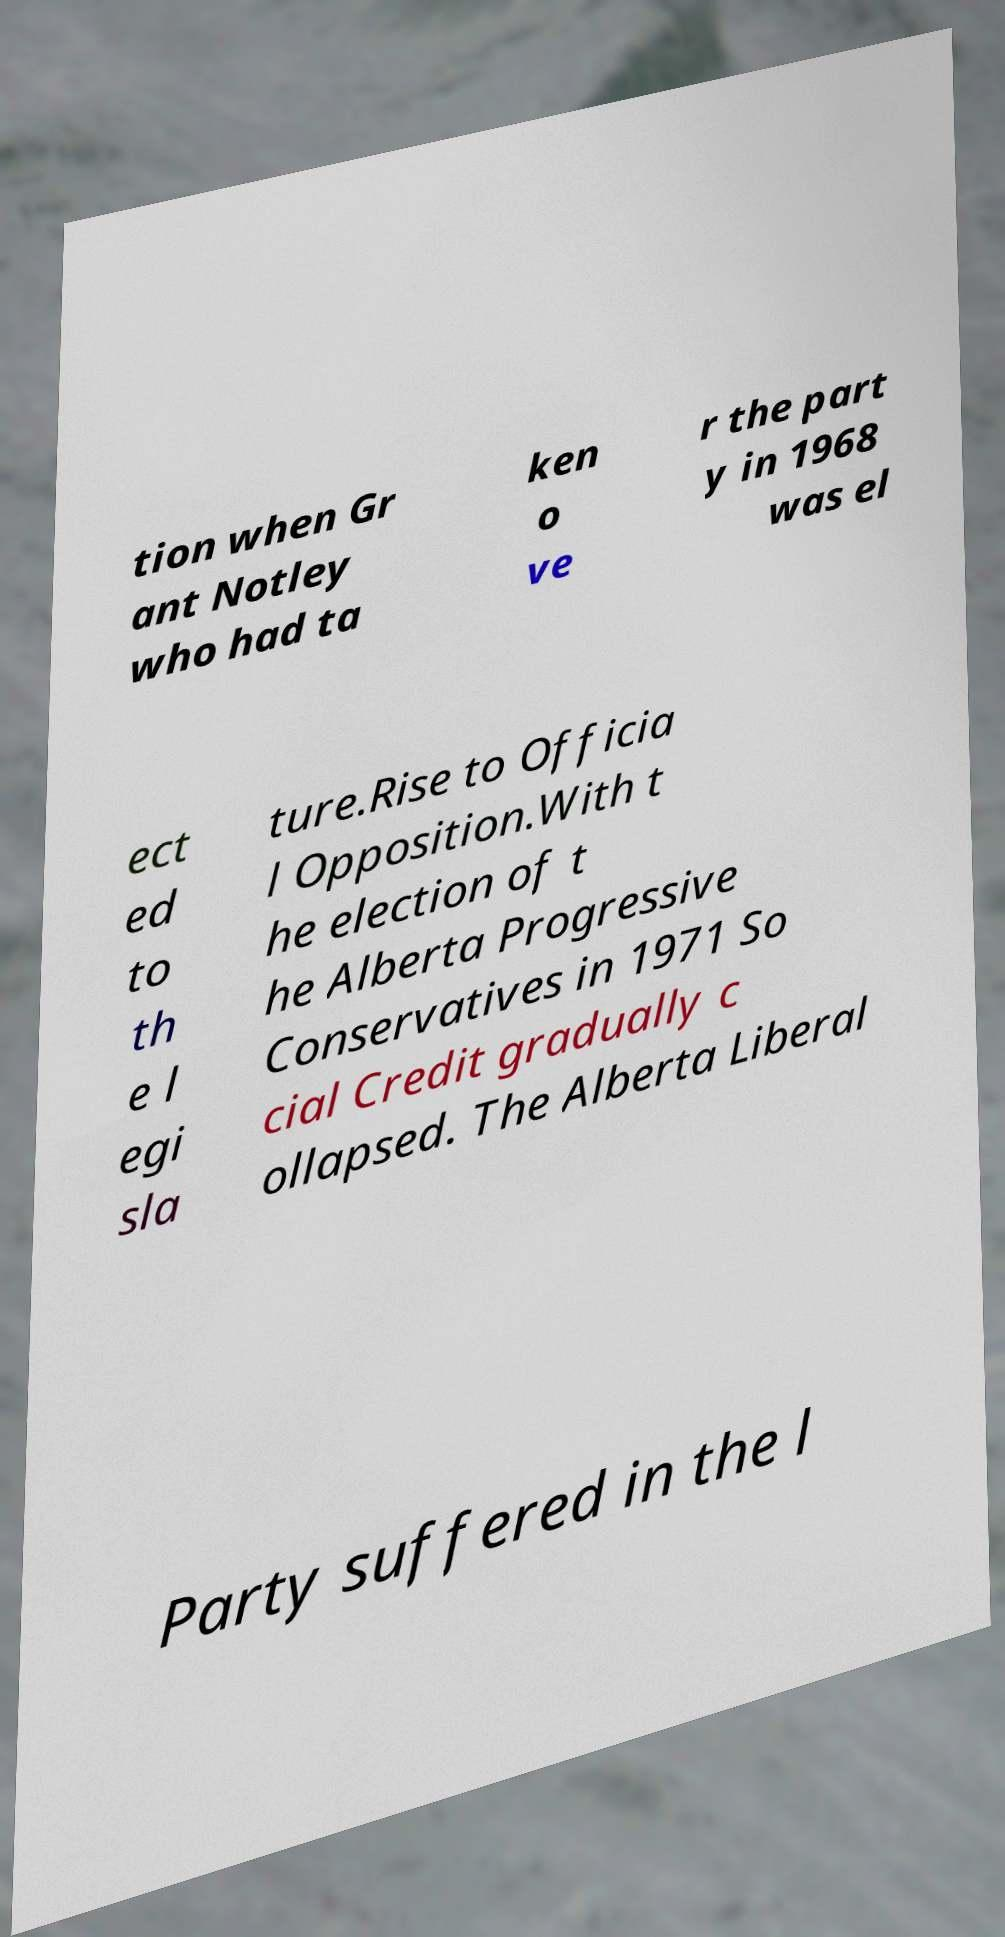What messages or text are displayed in this image? I need them in a readable, typed format. tion when Gr ant Notley who had ta ken o ve r the part y in 1968 was el ect ed to th e l egi sla ture.Rise to Officia l Opposition.With t he election of t he Alberta Progressive Conservatives in 1971 So cial Credit gradually c ollapsed. The Alberta Liberal Party suffered in the l 